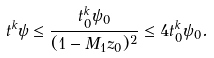<formula> <loc_0><loc_0><loc_500><loc_500>t ^ { k } \psi \leq \frac { t _ { 0 } ^ { k } \psi _ { 0 } } { ( 1 - M _ { 1 } z _ { 0 } ) ^ { 2 } } \leq 4 t _ { 0 } ^ { k } \psi _ { 0 } .</formula> 